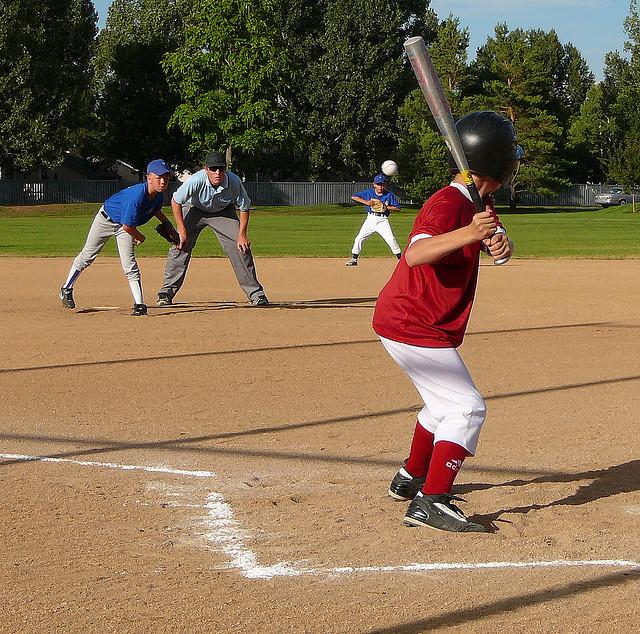Are the pitcher and batter on the same team?
Keep it brief. No. Why are some players wearing blue shirts instead of red?
Give a very brief answer. Other team. What color is the batter's shirt?
Give a very brief answer. Red. Is this a little league game?
Write a very short answer. Yes. What sport is shown?
Quick response, please. Baseball. 